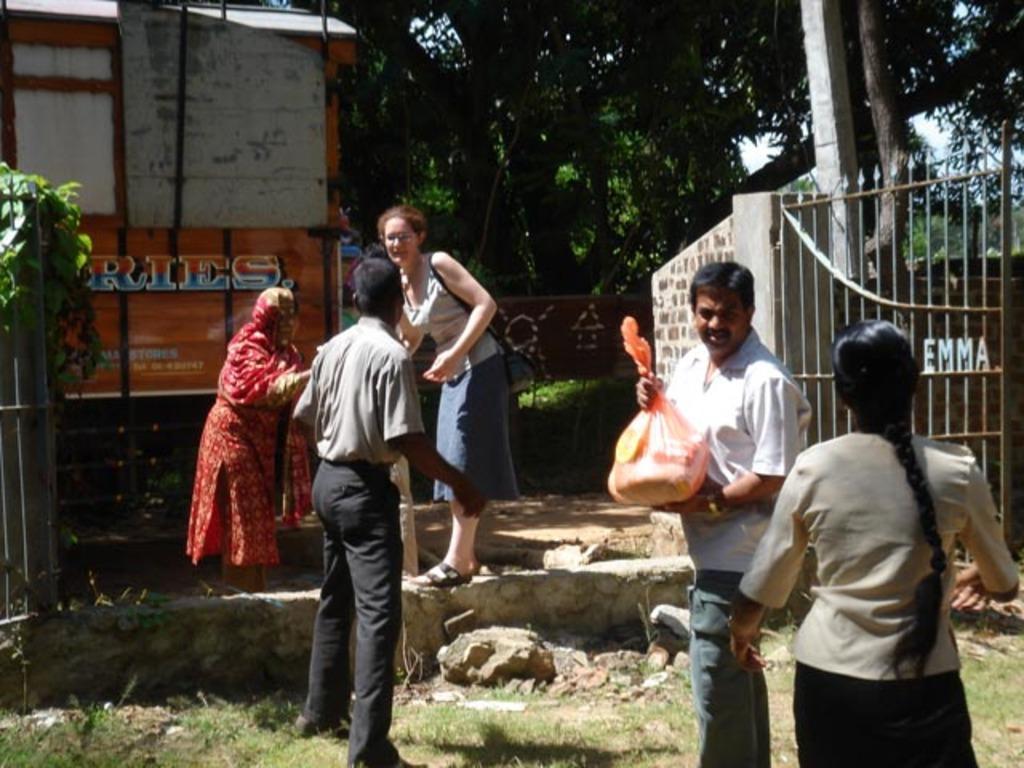Could you give a brief overview of what you see in this image? In this image we can see group of people standing on the ground. One person is holding a bag in his hand. A woman is wearing a bag. In the background we can see a gate,vehicle and group of trees. 